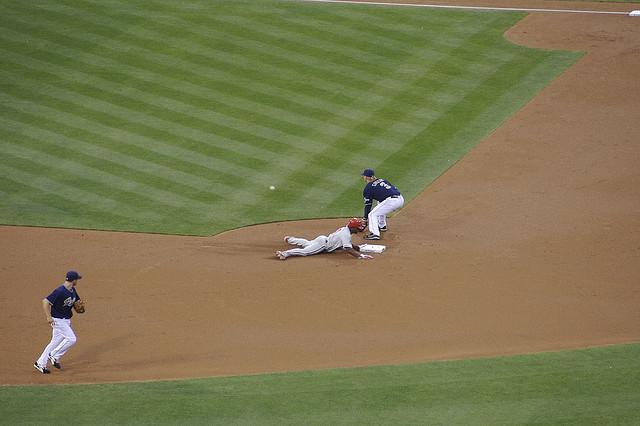How many players are on the field?
Give a very brief answer. 3. How many vases are reflected in the mirror?
Give a very brief answer. 0. 